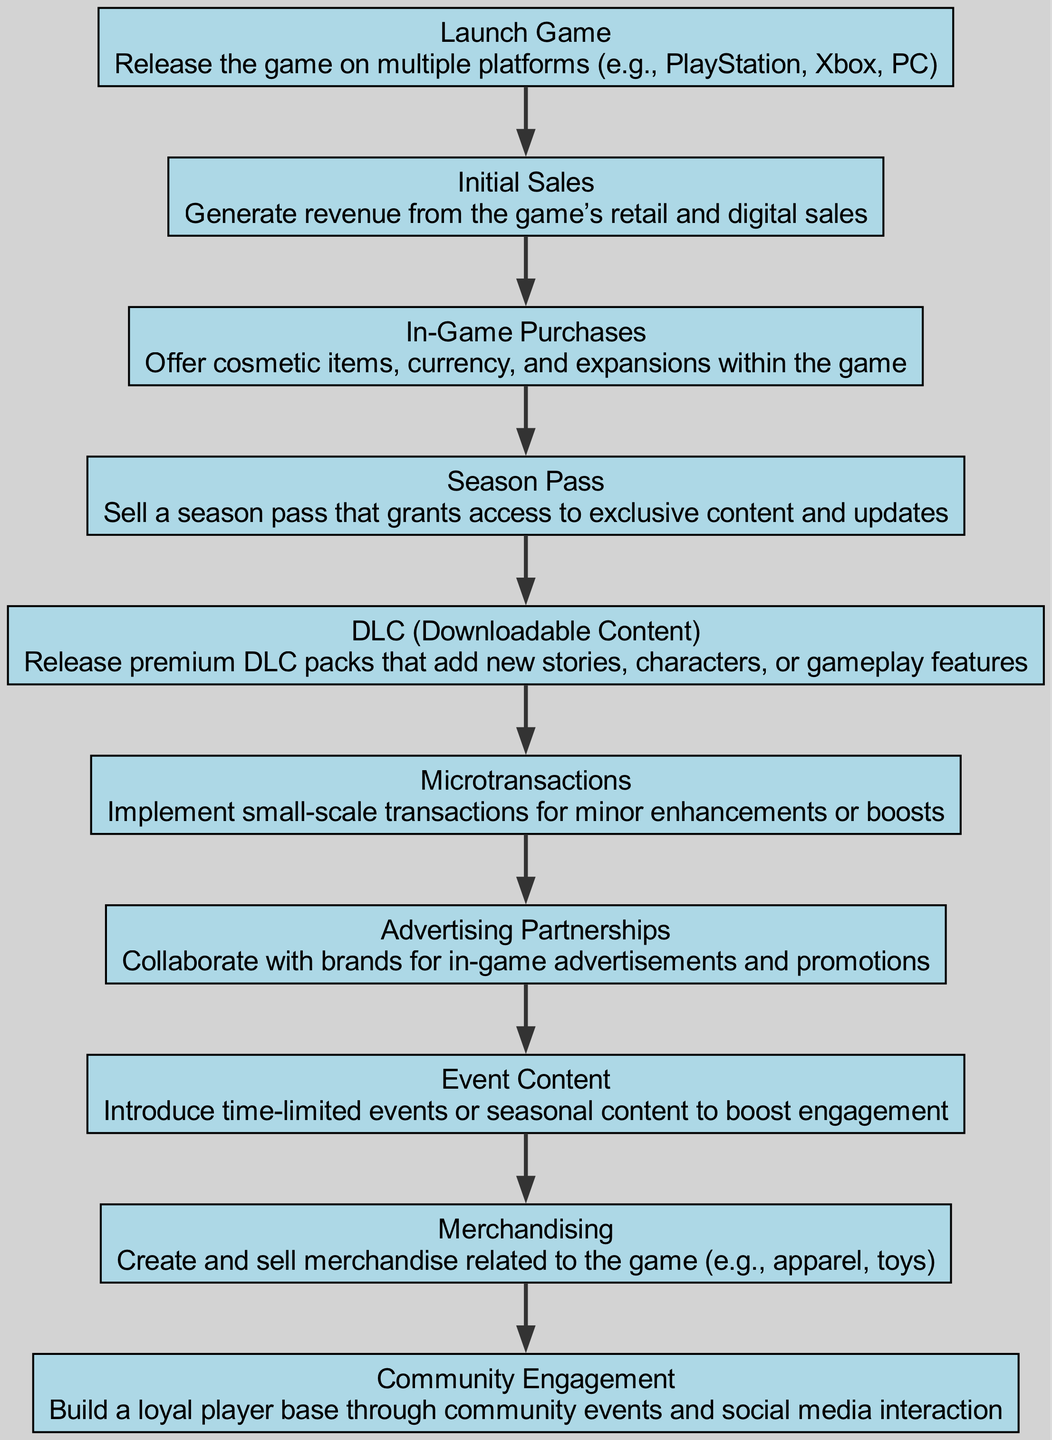What is the starting point of the monetization flow? The flow begins with the "Launch Game" node, which represents the initial step of releasing the game on various platforms.
Answer: Launch Game How many monetization strategies are listed in the diagram? There are 10 unique nodes in the diagram, each representing a different monetization strategy.
Answer: 10 Which monetization strategy is immediately after "Initial Sales"? After "Initial Sales," the next strategy listed is "In-Game Purchases," indicating a progression towards additional revenue opportunities.
Answer: In-Game Purchases What is the last monetization strategy mentioned in the flow? The final node in the flow is "Community Engagement," showing a strategy focused on building a loyal player base.
Answer: Community Engagement Which monetization strategy follows both "Season Pass" and "DLC"? Both "Season Pass" and "DLC" lead to "Microtransactions," signifying a connection to ongoing revenue opportunities.
Answer: Microtransactions Identify the node associated with time-limited content. The node that corresponds to time-limited content is "Event Content," indicating the introduction of seasonal or limited-time gaming experiences.
Answer: Event Content How does "Advertising Partnerships" fit within the monetization flow? "Advertising Partnerships" follows "In-Game Purchases," suggesting it is another opportunity for revenue generation that complements in-game monetization efforts.
Answer: After In-Game Purchases What is the purpose of the "Merchandising" node in the flow? "Merchandising" is intended to create additional revenue through the sale of game-related products, diversifying the income sources beyond the game itself.
Answer: Sale of merchandise What is the relationship between "Community Engagement" and overall revenue strategies? "Community Engagement" is the final step, contributing to sustaining player interest and loyalty, which can indirectly boost revenues through other strategies.
Answer: Sustaining player interest 